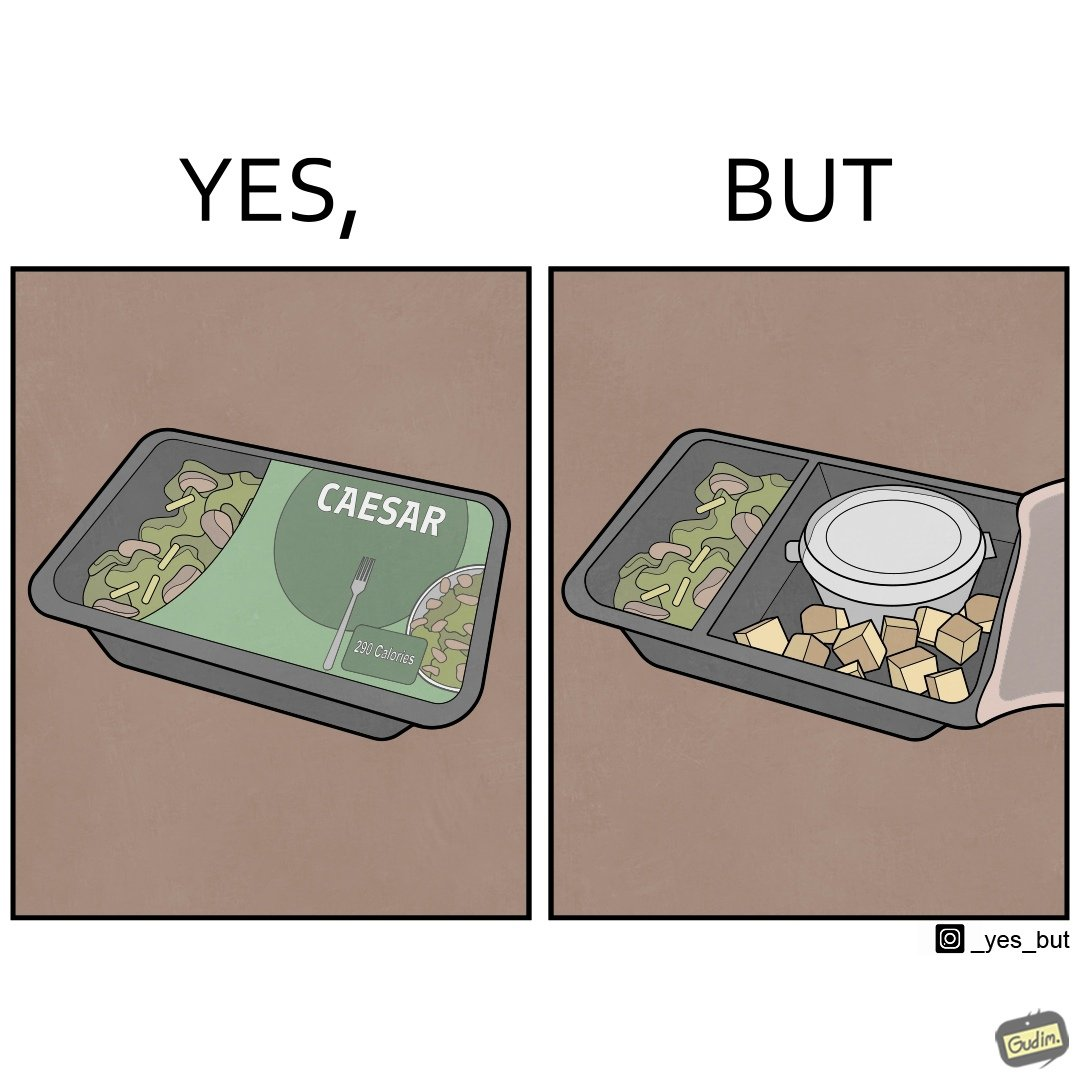Provide a description of this image. Image is funny because the box of salad was marketed in a way that showed a lot more salad content than was really present inside it. 